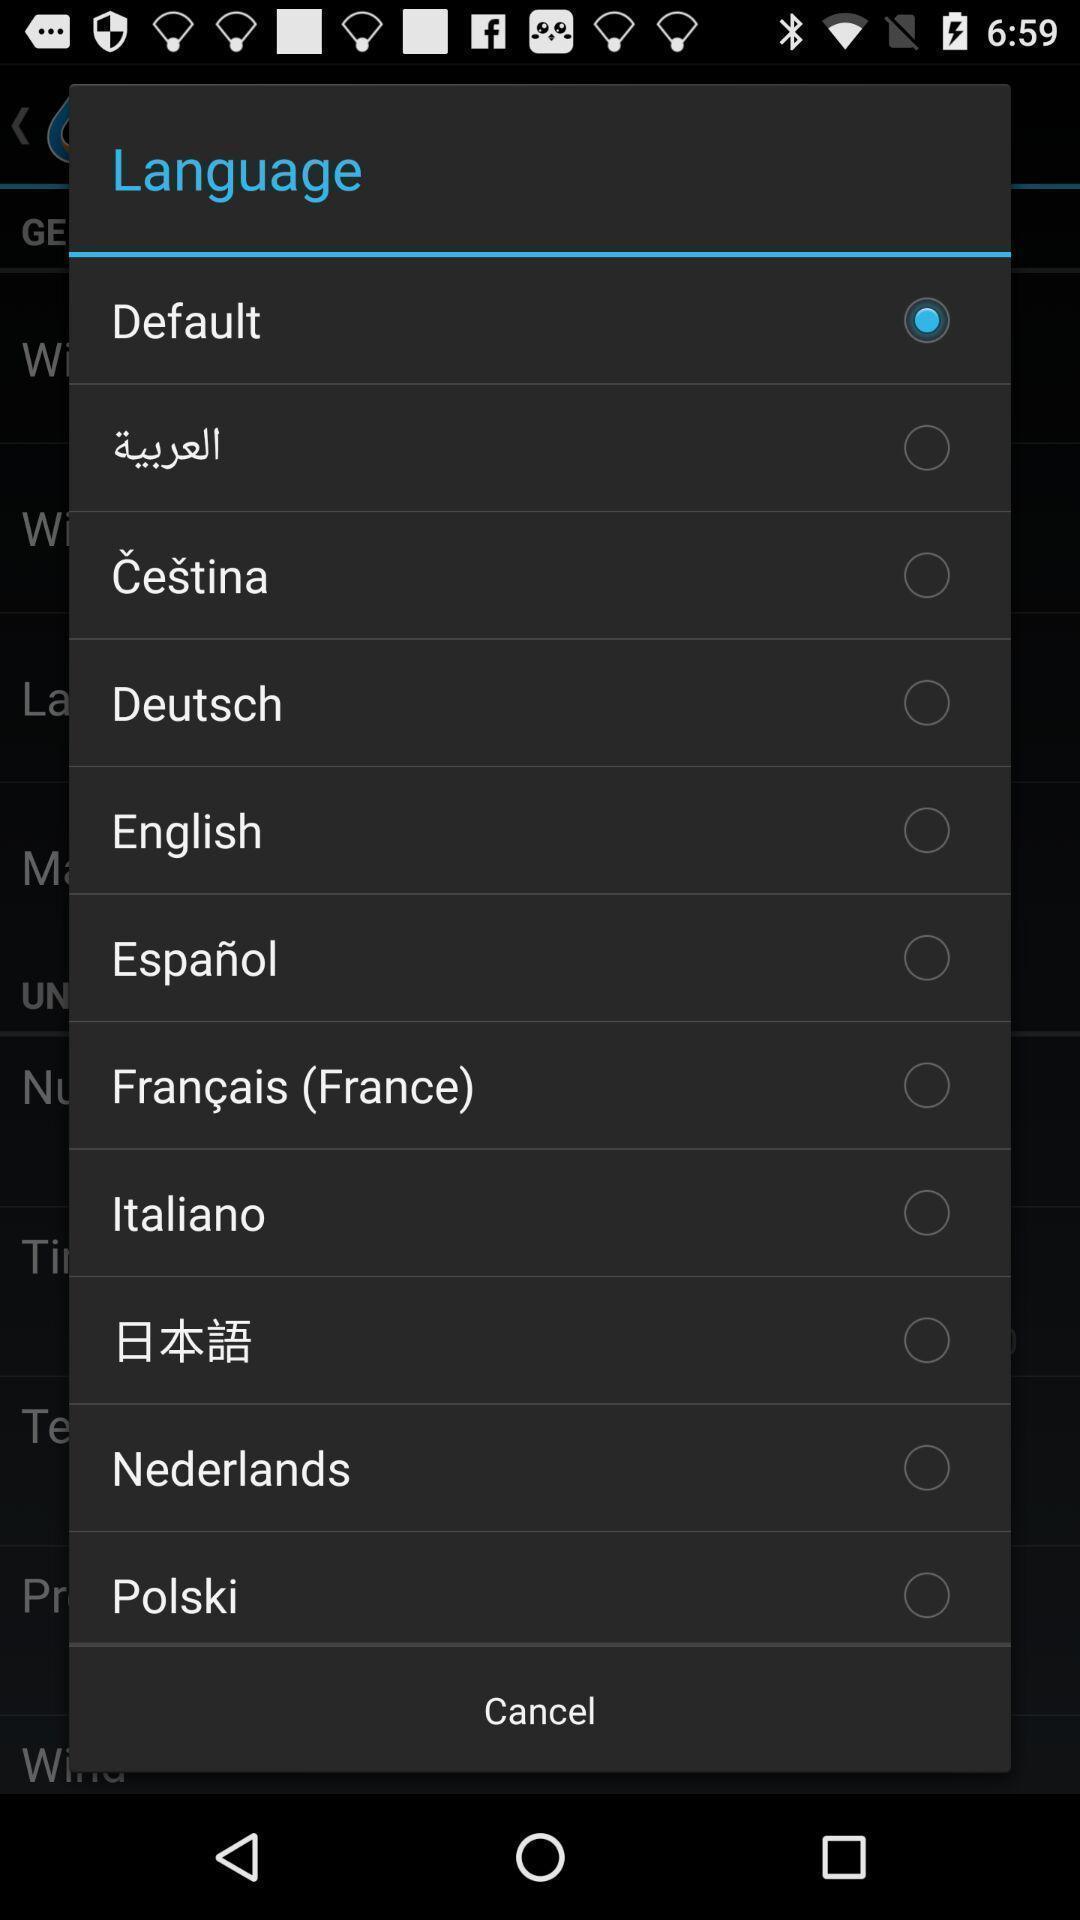Describe the content in this image. Popup showing list of languages to choose. 